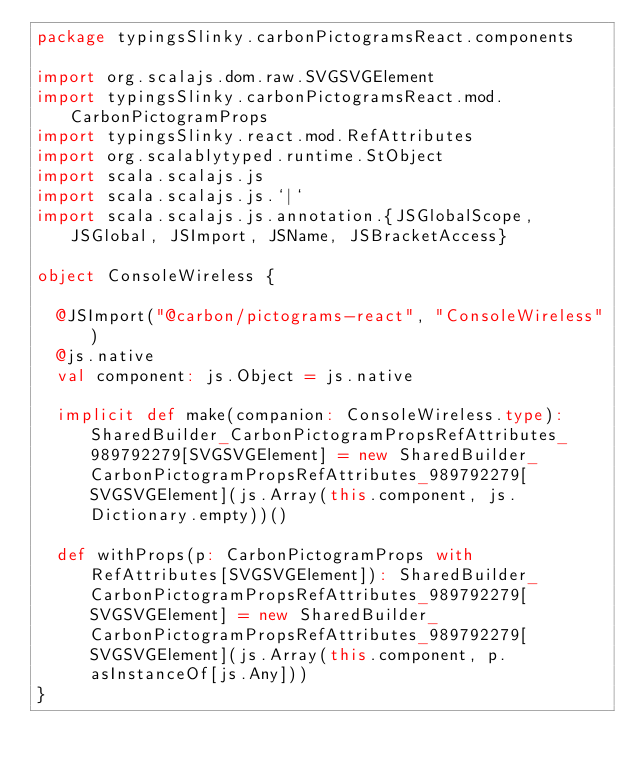Convert code to text. <code><loc_0><loc_0><loc_500><loc_500><_Scala_>package typingsSlinky.carbonPictogramsReact.components

import org.scalajs.dom.raw.SVGSVGElement
import typingsSlinky.carbonPictogramsReact.mod.CarbonPictogramProps
import typingsSlinky.react.mod.RefAttributes
import org.scalablytyped.runtime.StObject
import scala.scalajs.js
import scala.scalajs.js.`|`
import scala.scalajs.js.annotation.{JSGlobalScope, JSGlobal, JSImport, JSName, JSBracketAccess}

object ConsoleWireless {
  
  @JSImport("@carbon/pictograms-react", "ConsoleWireless")
  @js.native
  val component: js.Object = js.native
  
  implicit def make(companion: ConsoleWireless.type): SharedBuilder_CarbonPictogramPropsRefAttributes_989792279[SVGSVGElement] = new SharedBuilder_CarbonPictogramPropsRefAttributes_989792279[SVGSVGElement](js.Array(this.component, js.Dictionary.empty))()
  
  def withProps(p: CarbonPictogramProps with RefAttributes[SVGSVGElement]): SharedBuilder_CarbonPictogramPropsRefAttributes_989792279[SVGSVGElement] = new SharedBuilder_CarbonPictogramPropsRefAttributes_989792279[SVGSVGElement](js.Array(this.component, p.asInstanceOf[js.Any]))
}
</code> 